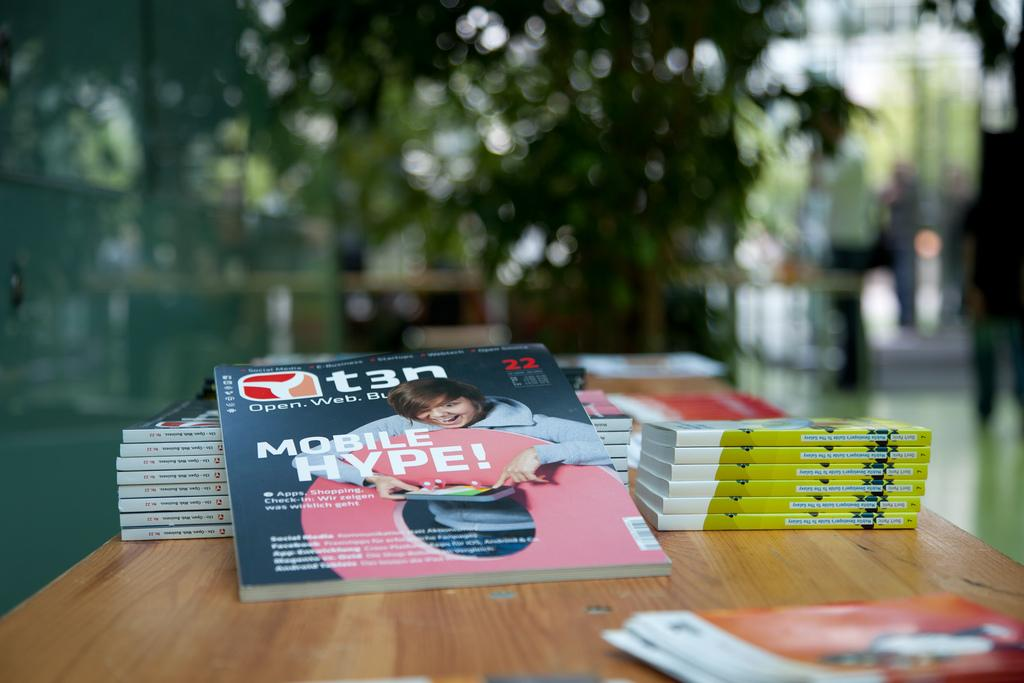Provide a one-sentence caption for the provided image. T3n book about mobile hype for social media and business. 